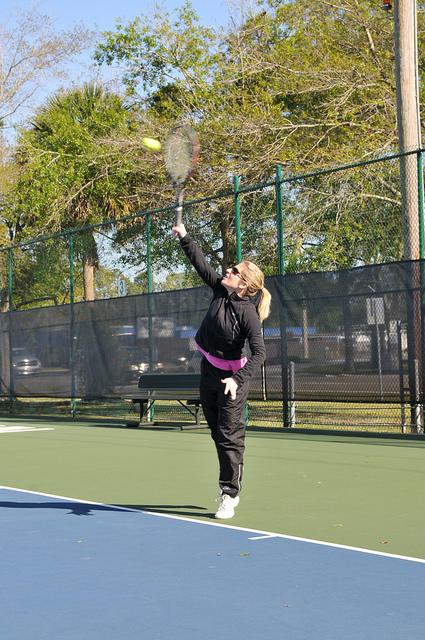What is the woman doing?
Write a very short answer. Playing tennis. Does the woman have a ponytail?
Give a very brief answer. Yes. What color pants is she wearing?
Write a very short answer. Black. 